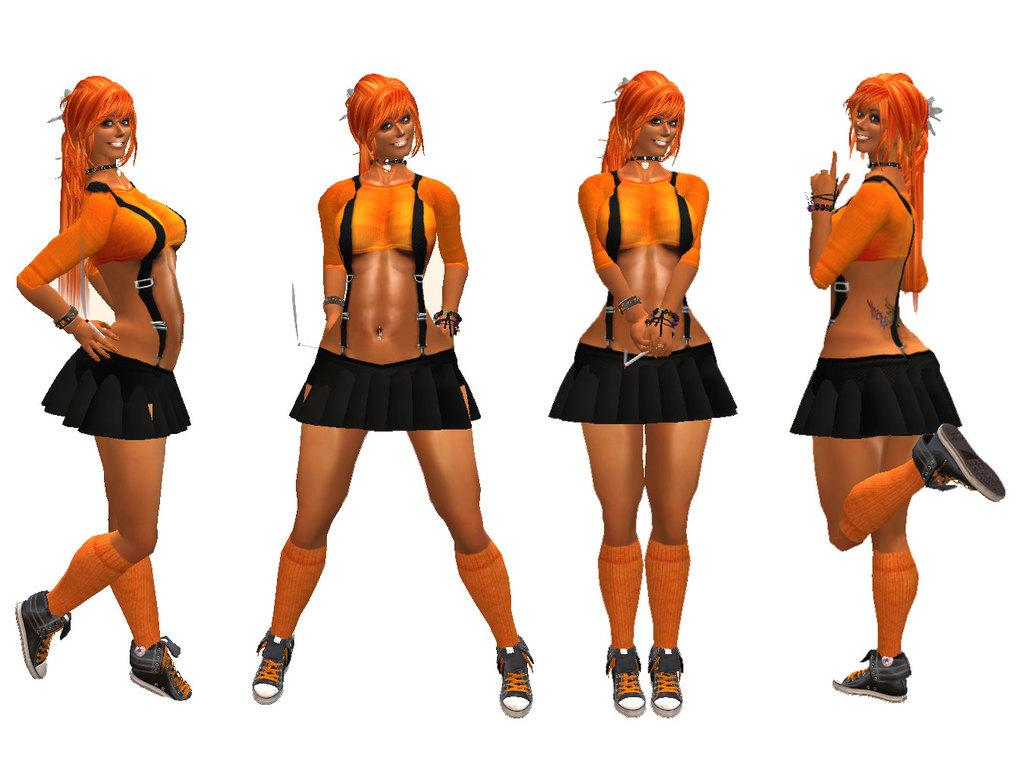How many people are in the image? There are four women in the image. What is the facial expression of the women in the image? The women are smiling. What is the color of the surface the women are standing on? The women are standing on a white surface. What type of trick are the women performing in the image? There is no indication of a trick being performed in the image; the women are simply standing and smiling. 